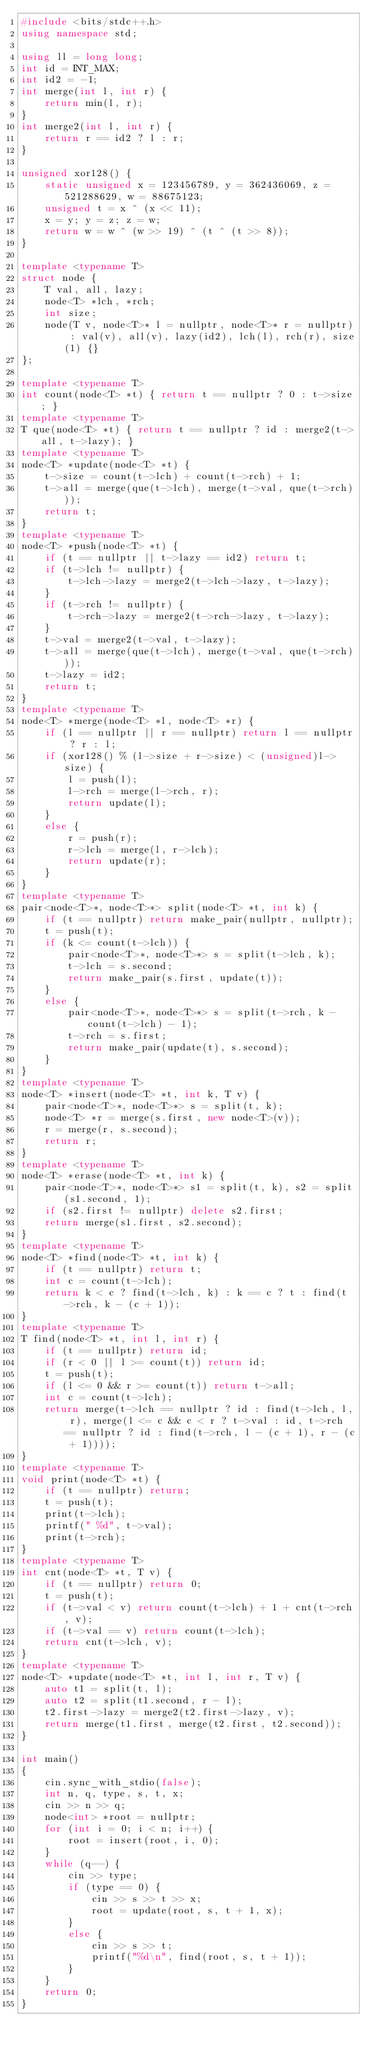<code> <loc_0><loc_0><loc_500><loc_500><_C++_>#include <bits/stdc++.h>
using namespace std;
 
using ll = long long;
int id = INT_MAX;
int id2 = -1;
int merge(int l, int r) {
    return min(l, r);
}
int merge2(int l, int r) {
    return r == id2 ? l : r;
}
 
unsigned xor128() {
    static unsigned x = 123456789, y = 362436069, z = 521288629, w = 88675123;
    unsigned t = x ^ (x << 11);
    x = y; y = z; z = w;
    return w = w ^ (w >> 19) ^ (t ^ (t >> 8));
}
 
template <typename T>
struct node {
    T val, all, lazy;
    node<T> *lch, *rch;
    int size;
    node(T v, node<T>* l = nullptr, node<T>* r = nullptr) : val(v), all(v), lazy(id2), lch(l), rch(r), size(1) {}
};
 
template <typename T>
int count(node<T> *t) { return t == nullptr ? 0 : t->size; }
template <typename T>
T que(node<T> *t) { return t == nullptr ? id : merge2(t->all, t->lazy); }
template <typename T>
node<T> *update(node<T> *t) {
    t->size = count(t->lch) + count(t->rch) + 1;
    t->all = merge(que(t->lch), merge(t->val, que(t->rch)));
    return t;
}
template <typename T>
node<T> *push(node<T> *t) {
    if (t == nullptr || t->lazy == id2) return t;
    if (t->lch != nullptr) {
        t->lch->lazy = merge2(t->lch->lazy, t->lazy);
    }
    if (t->rch != nullptr) {
        t->rch->lazy = merge2(t->rch->lazy, t->lazy);
    }
    t->val = merge2(t->val, t->lazy);
    t->all = merge(que(t->lch), merge(t->val, que(t->rch)));
    t->lazy = id2;
    return t;
}
template <typename T>
node<T> *merge(node<T> *l, node<T> *r) {
    if (l == nullptr || r == nullptr) return l == nullptr ? r : l;
    if (xor128() % (l->size + r->size) < (unsigned)l->size) {
        l = push(l);
        l->rch = merge(l->rch, r);
        return update(l);
    }
    else {
        r = push(r);
        r->lch = merge(l, r->lch);
        return update(r);
    }
}
template <typename T>
pair<node<T>*, node<T>*> split(node<T> *t, int k) {
    if (t == nullptr) return make_pair(nullptr, nullptr);
    t = push(t);
    if (k <= count(t->lch)) {
        pair<node<T>*, node<T>*> s = split(t->lch, k);
        t->lch = s.second;
        return make_pair(s.first, update(t));
    }
    else {
        pair<node<T>*, node<T>*> s = split(t->rch, k - count(t->lch) - 1);
        t->rch = s.first;
        return make_pair(update(t), s.second);
    }
}
template <typename T>
node<T> *insert(node<T> *t, int k, T v) {
    pair<node<T>*, node<T>*> s = split(t, k);
    node<T> *r = merge(s.first, new node<T>(v));
    r = merge(r, s.second);
    return r;
}
template <typename T>
node<T> *erase(node<T> *t, int k) {
    pair<node<T>*, node<T>*> s1 = split(t, k), s2 = split(s1.second, 1);
    if (s2.first != nullptr) delete s2.first;
    return merge(s1.first, s2.second);
}
template <typename T>
node<T> *find(node<T> *t, int k) {
    if (t == nullptr) return t;
    int c = count(t->lch);
    return k < c ? find(t->lch, k) : k == c ? t : find(t->rch, k - (c + 1));
}
template <typename T>
T find(node<T> *t, int l, int r) {
    if (t == nullptr) return id;
    if (r < 0 || l >= count(t)) return id;
    t = push(t);
    if (l <= 0 && r >= count(t)) return t->all;
    int c = count(t->lch);
    return merge(t->lch == nullptr ? id : find(t->lch, l, r), merge(l <= c && c < r ? t->val : id, t->rch == nullptr ? id : find(t->rch, l - (c + 1), r - (c + 1))));
}
template <typename T>
void print(node<T> *t) {
    if (t == nullptr) return;
    t = push(t);
    print(t->lch);
    printf(" %d", t->val);
    print(t->rch);
}
template <typename T>
int cnt(node<T> *t, T v) {
    if (t == nullptr) return 0;
    t = push(t);
    if (t->val < v) return count(t->lch) + 1 + cnt(t->rch, v);
    if (t->val == v) return count(t->lch);
    return cnt(t->lch, v);
}
template <typename T>
node<T> *update(node<T> *t, int l, int r, T v) {
    auto t1 = split(t, l);
    auto t2 = split(t1.second, r - l);
    t2.first->lazy = merge2(t2.first->lazy, v);
    return merge(t1.first, merge(t2.first, t2.second));
}
 
int main()
{
    cin.sync_with_stdio(false);
    int n, q, type, s, t, x;
    cin >> n >> q;
    node<int> *root = nullptr;
    for (int i = 0; i < n; i++) {
        root = insert(root, i, 0);
    }
    while (q--) {
        cin >> type;
        if (type == 0) {
            cin >> s >> t >> x;
            root = update(root, s, t + 1, x);
        }
        else {
            cin >> s >> t;
            printf("%d\n", find(root, s, t + 1));
        }
    }
    return 0;
}</code> 